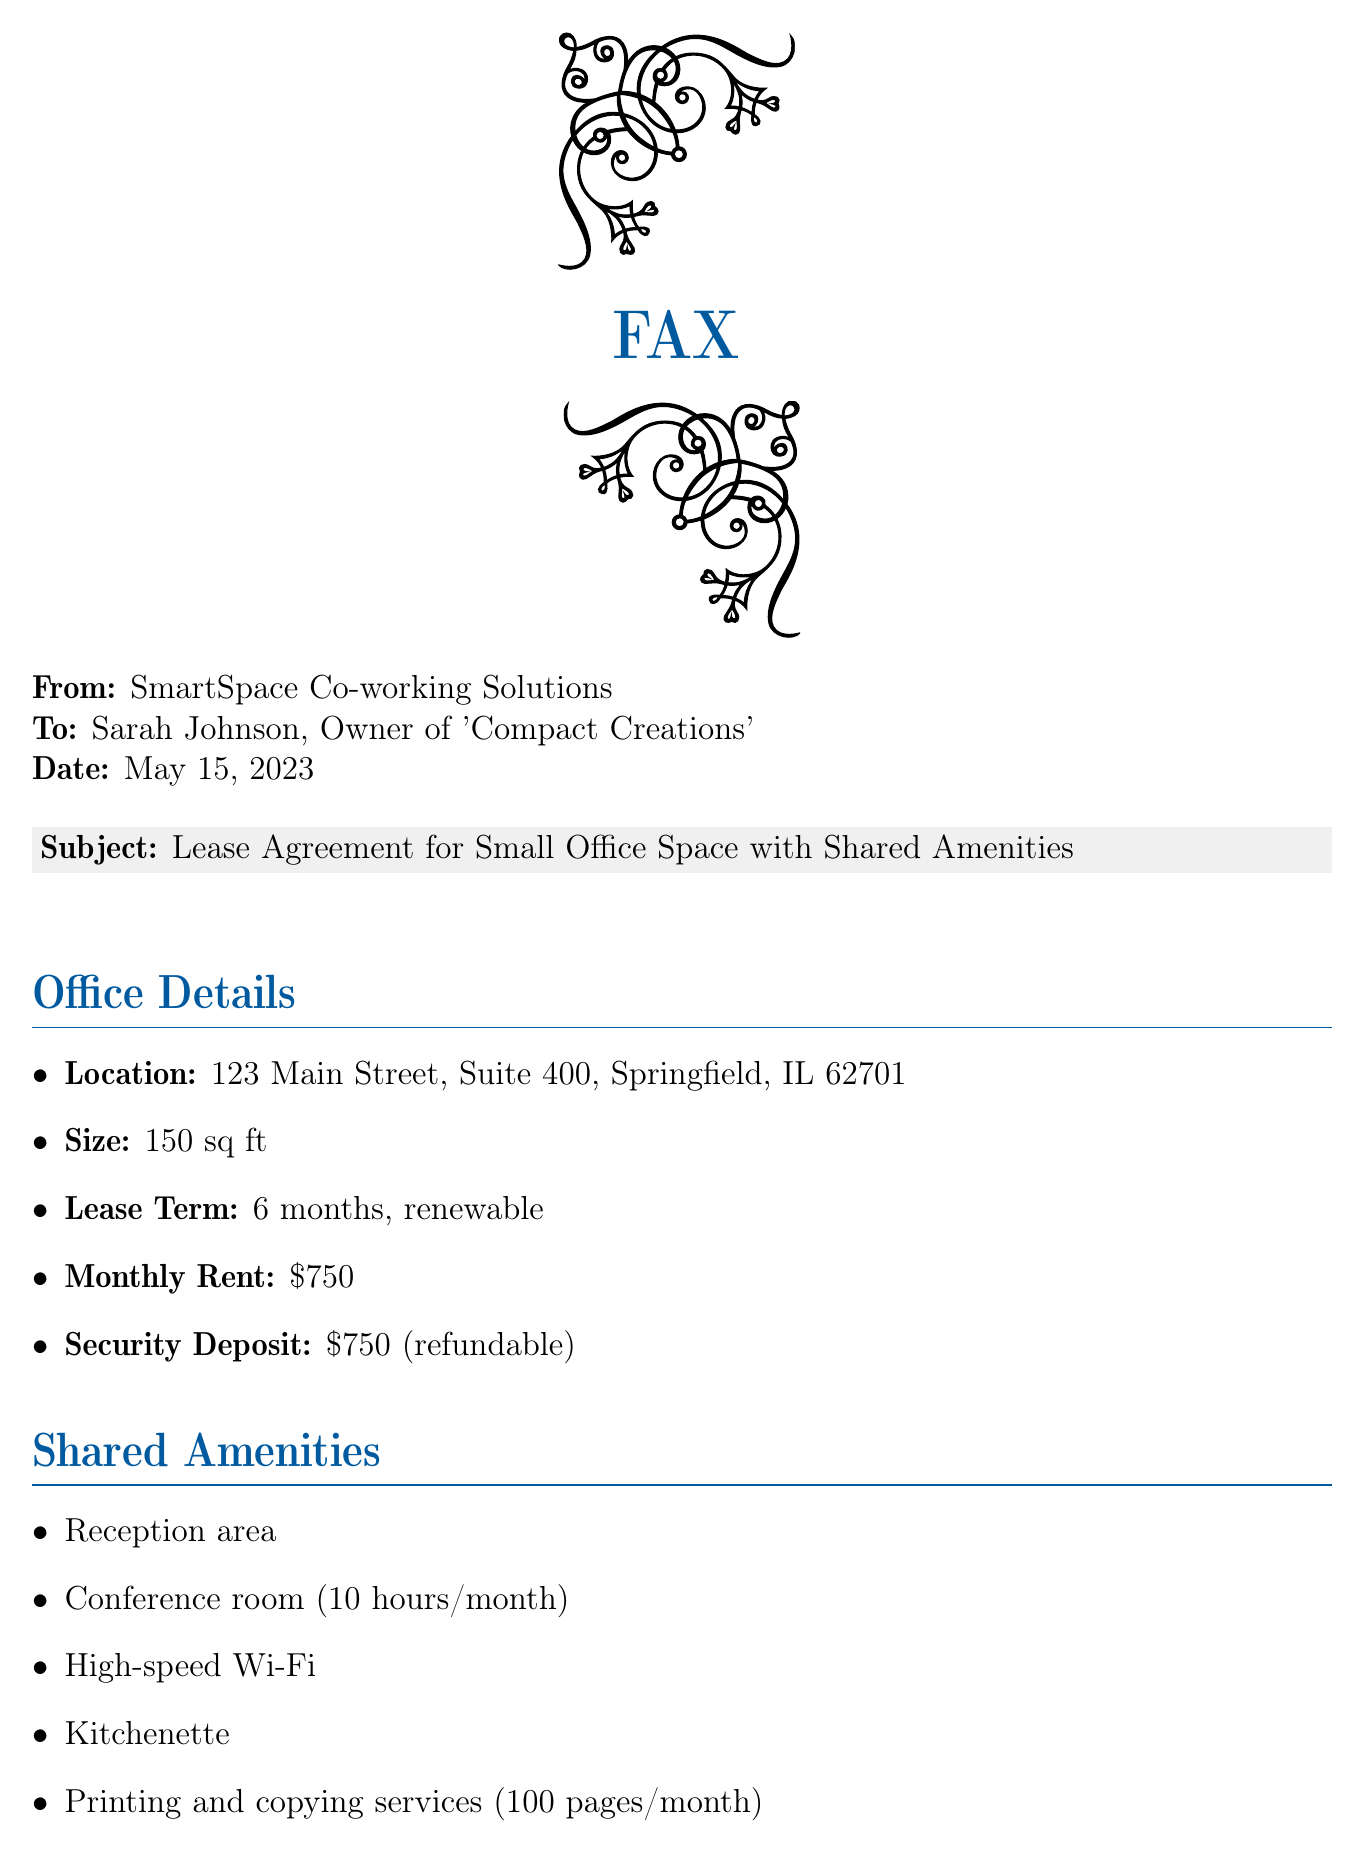What is the location of the office space? The location is specified as the address in the document.
Answer: 123 Main Street, Suite 400, Springfield, IL 62701 What is the size of the office? The document states the size of the office space.
Answer: 150 sq ft What is the monthly rent? The monthly rent is explicitly mentioned in the lease agreement.
Answer: $750 What is the term of the lease? The document specifies the duration of the lease term.
Answer: 6 months, renewable How much is the security deposit? The security deposit amount is detailed in the document.
Answer: $750 (refundable) What shared amenity is available for 10 hours per month? The document lists amenities and specifies the usage limit for the conference room.
Answer: Conference room Is there a notice period for termination? The notice period is mentioned under additional terms in the agreement.
Answer: 30 days Can utilities be included in the rent? The document explicitly states whether utilities are included or not.
Answer: Yes Can the office space be upgraded? The document notes options for upgrading the space.
Answer: Yes What is included in the printing service? The document outlines the limits of the printing and copying services.
Answer: 100 pages/month 